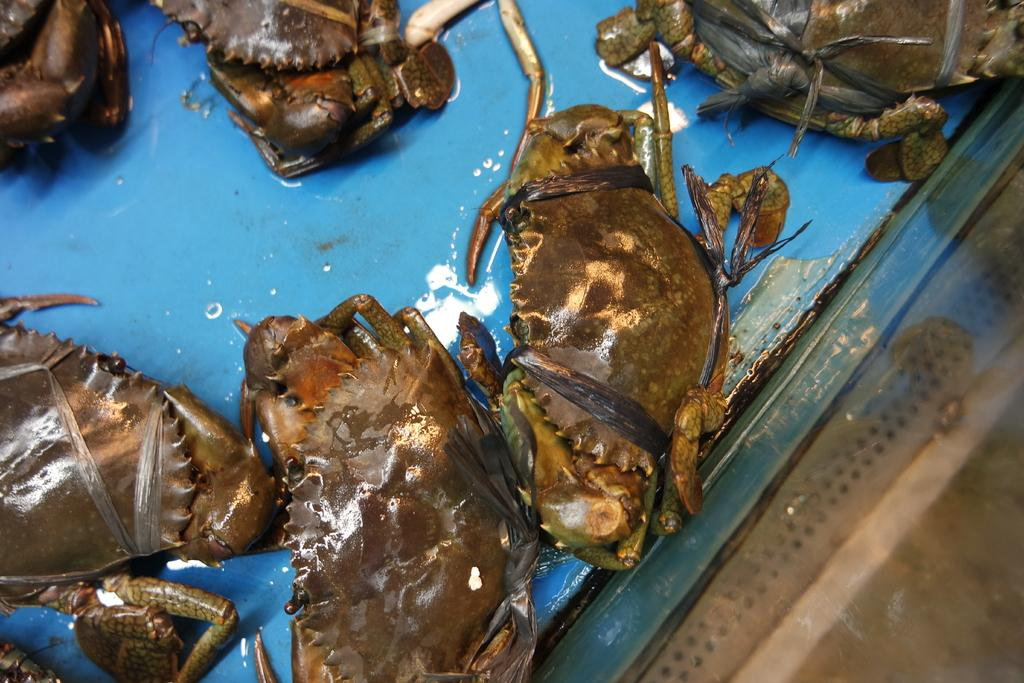What type of animals are present on the surface in the image? There are crabs on the surface in the image. What type of metal is used to make the crib in the image? There is no crib present in the image; it only features crabs on a surface. What type of fabric is draped over the silk in the image? There is no silk present in the image; it only features crabs on a surface. 